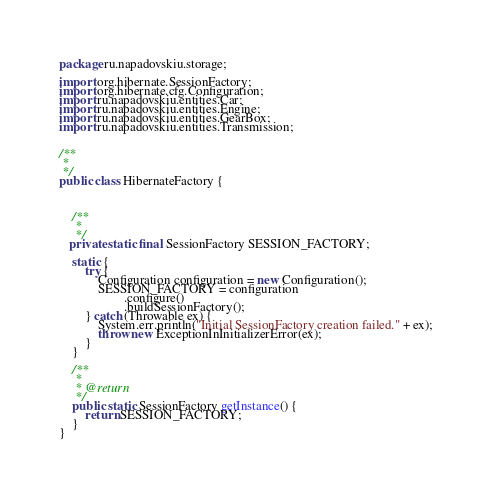<code> <loc_0><loc_0><loc_500><loc_500><_Java_>package ru.napadovskiu.storage;

import org.hibernate.SessionFactory;
import org.hibernate.cfg.Configuration;
import ru.napadovskiu.entities.Car;
import ru.napadovskiu.entities.Engine;
import ru.napadovskiu.entities.GearBox;
import ru.napadovskiu.entities.Transmission;


/**
 *
 */
public class HibernateFactory {



    /**
     *
     */
   private static final SessionFactory SESSION_FACTORY;

    static {
        try {
            Configuration configuration = new Configuration();
            SESSION_FACTORY = configuration
                    .configure()
                    .buildSessionFactory();
        } catch (Throwable ex) {
            System.err.println("Initial SessionFactory creation failed." + ex);
            throw new ExceptionInInitializerError(ex);
        }
    }

    /**
     *
     * @return
     */
    public static SessionFactory getInstance() {
        return SESSION_FACTORY;
    }
}
</code> 